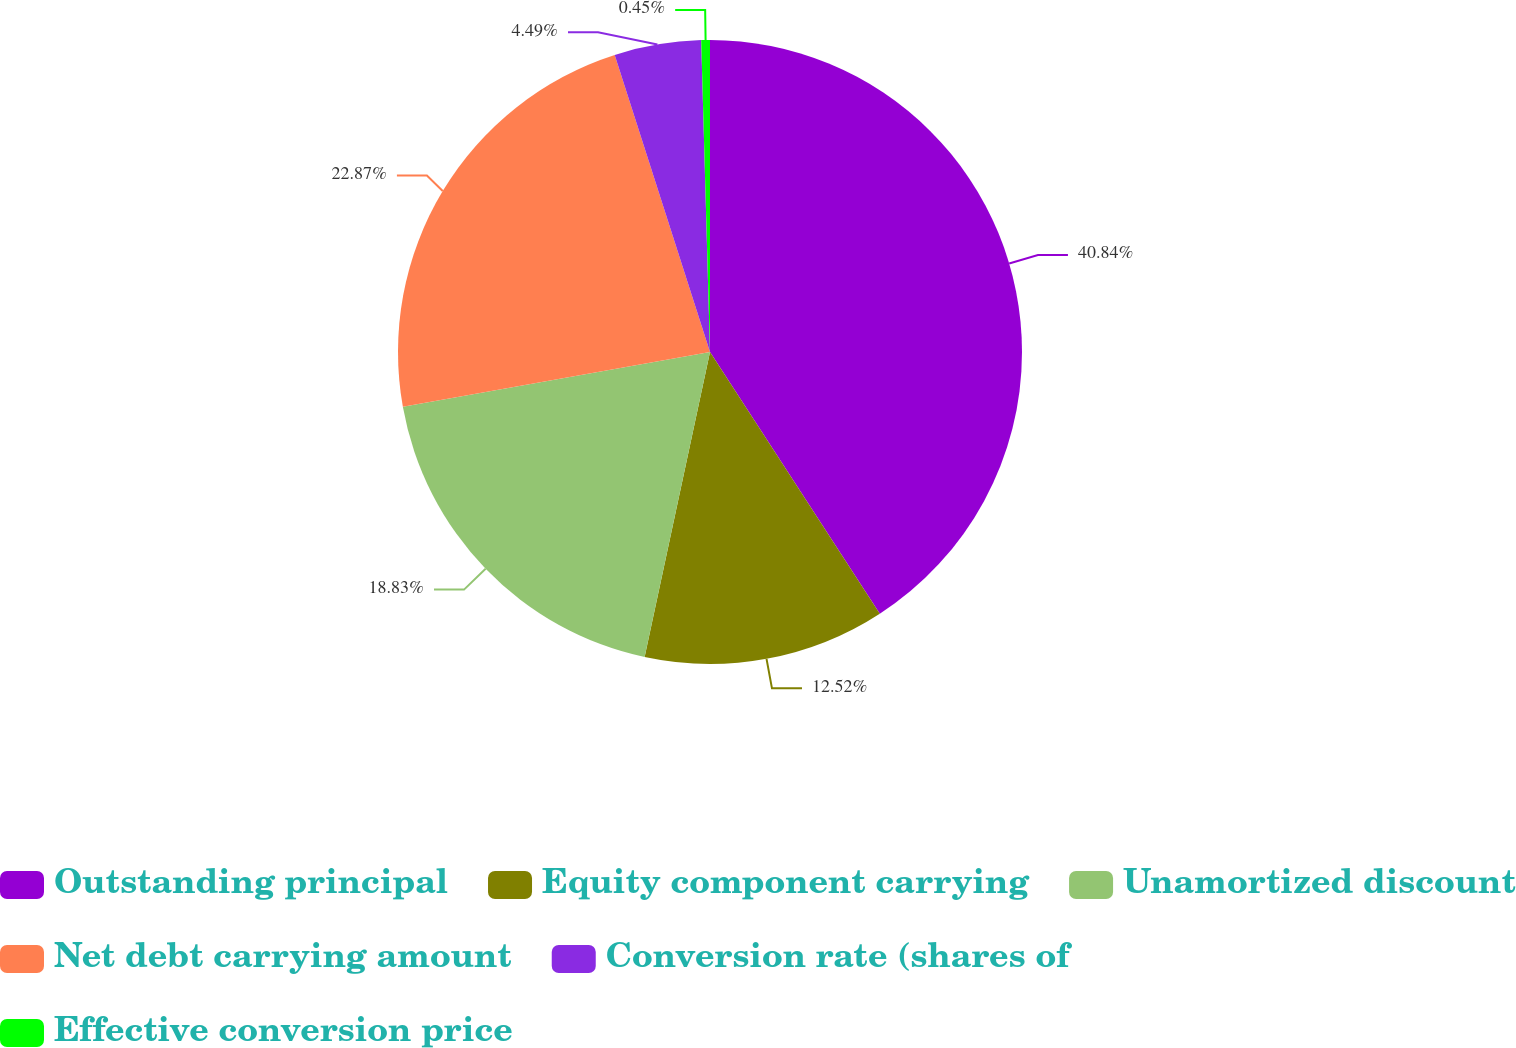<chart> <loc_0><loc_0><loc_500><loc_500><pie_chart><fcel>Outstanding principal<fcel>Equity component carrying<fcel>Unamortized discount<fcel>Net debt carrying amount<fcel>Conversion rate (shares of<fcel>Effective conversion price<nl><fcel>40.84%<fcel>12.52%<fcel>18.83%<fcel>22.87%<fcel>4.49%<fcel>0.45%<nl></chart> 